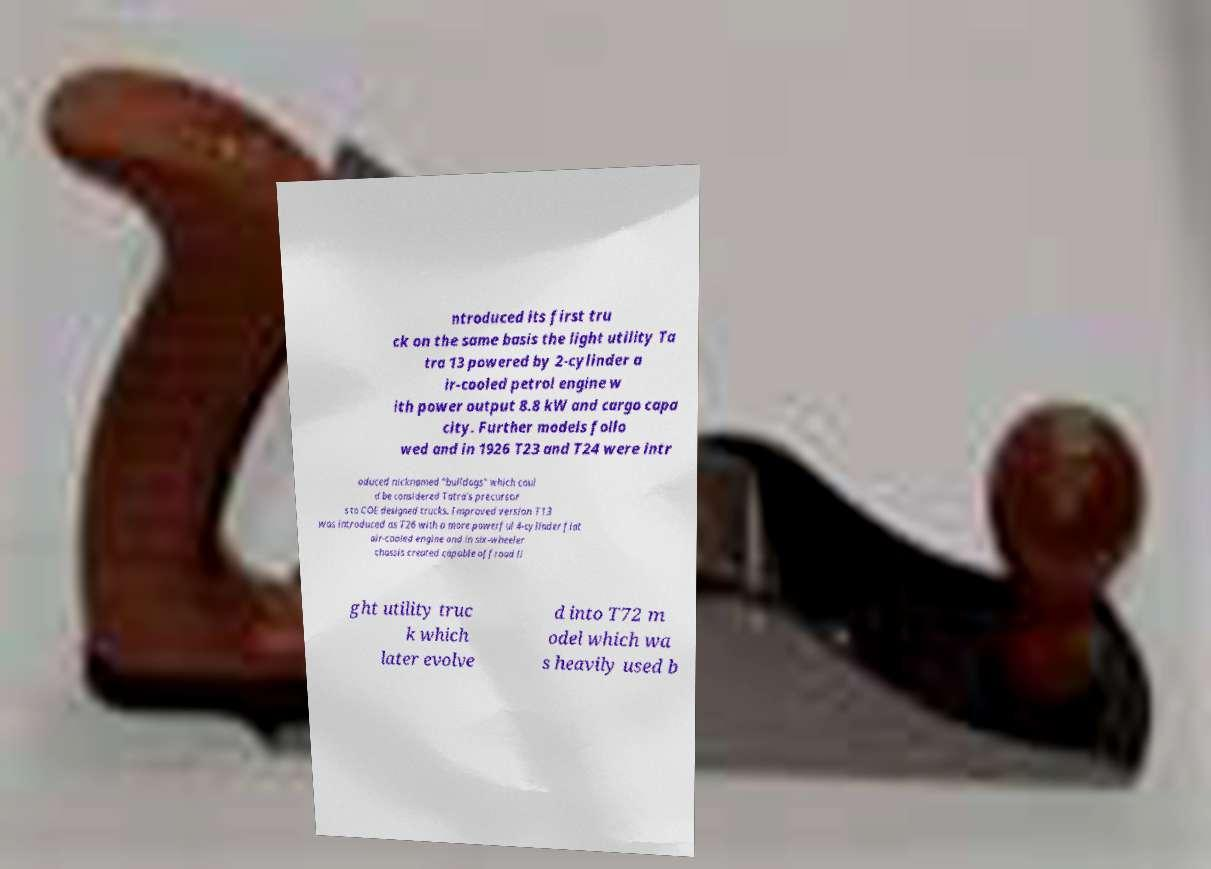Please identify and transcribe the text found in this image. ntroduced its first tru ck on the same basis the light utility Ta tra 13 powered by 2-cylinder a ir-cooled petrol engine w ith power output 8.8 kW and cargo capa city. Further models follo wed and in 1926 T23 and T24 were intr oduced nicknamed "bulldogs" which coul d be considered Tatra's precursor s to COE designed trucks. Improved version T13 was introduced as T26 with a more powerful 4-cylinder flat air-cooled engine and in six-wheeler chassis created capable offroad li ght utility truc k which later evolve d into T72 m odel which wa s heavily used b 